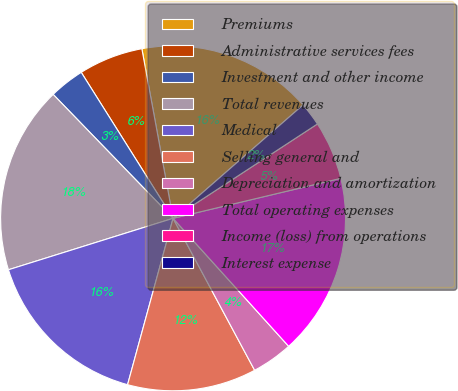Convert chart. <chart><loc_0><loc_0><loc_500><loc_500><pie_chart><fcel>Premiums<fcel>Administrative services fees<fcel>Investment and other income<fcel>Total revenues<fcel>Medical<fcel>Selling general and<fcel>Depreciation and amortization<fcel>Total operating expenses<fcel>Income (loss) from operations<fcel>Interest expense<nl><fcel>16.48%<fcel>6.04%<fcel>3.3%<fcel>17.58%<fcel>15.93%<fcel>12.09%<fcel>3.85%<fcel>17.03%<fcel>5.49%<fcel>2.2%<nl></chart> 